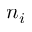<formula> <loc_0><loc_0><loc_500><loc_500>n _ { i }</formula> 